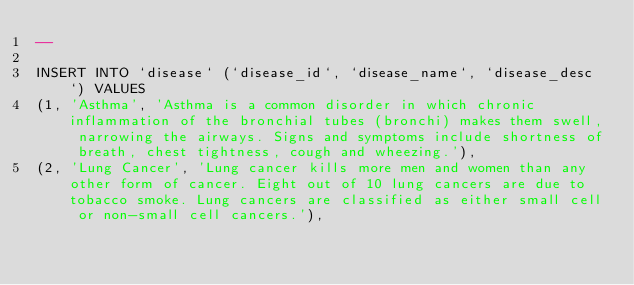<code> <loc_0><loc_0><loc_500><loc_500><_SQL_>--

INSERT INTO `disease` (`disease_id`, `disease_name`, `disease_desc`) VALUES
(1, 'Asthma', 'Asthma is a common disorder in which chronic inflammation of the bronchial tubes (bronchi) makes them swell, narrowing the airways. Signs and symptoms include shortness of breath, chest tightness, cough and wheezing.'),
(2, 'Lung Cancer', 'Lung cancer kills more men and women than any other form of cancer. Eight out of 10 lung cancers are due to tobacco smoke. Lung cancers are classified as either small cell or non-small cell cancers.'),</code> 